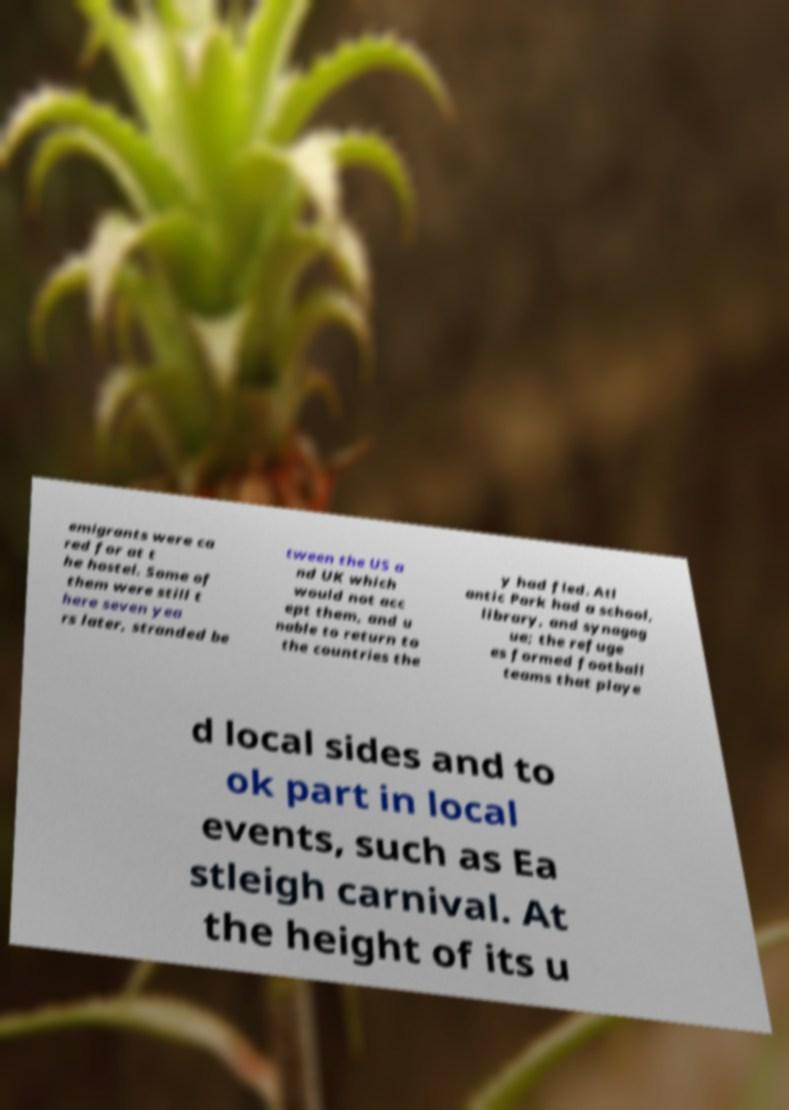For documentation purposes, I need the text within this image transcribed. Could you provide that? emigrants were ca red for at t he hostel. Some of them were still t here seven yea rs later, stranded be tween the US a nd UK which would not acc ept them, and u nable to return to the countries the y had fled. Atl antic Park had a school, library, and synagog ue; the refuge es formed football teams that playe d local sides and to ok part in local events, such as Ea stleigh carnival. At the height of its u 